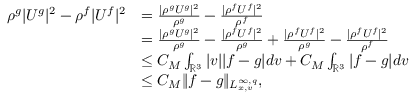<formula> <loc_0><loc_0><loc_500><loc_500>\begin{array} { r l } { \rho ^ { g } | U ^ { g } | ^ { 2 } - \rho ^ { f } | U ^ { f } | ^ { 2 } } & { = \frac { | \rho ^ { g } U ^ { g } | ^ { 2 } } { \rho ^ { g } } - \frac { | \rho ^ { f } U ^ { f } | ^ { 2 } } { \rho ^ { f } } } \\ & { = \frac { | \rho ^ { g } U ^ { g } | ^ { 2 } } { \rho ^ { g } } - \frac { | \rho ^ { f } U ^ { f } | ^ { 2 } } { \rho ^ { g } } + \frac { | \rho ^ { f } U ^ { f } | ^ { 2 } } { \rho ^ { g } } - \frac { | \rho ^ { f } U ^ { f } | ^ { 2 } } { \rho ^ { f } } } \\ & { \leq C _ { M } \int _ { \mathbb { R } ^ { 3 } } | v | | f - g | d v + C _ { M } \int _ { \mathbb { R } ^ { 3 } } | f - g | d v } \\ & { \leq C _ { M } \| f - g \| _ { L _ { x , v } ^ { \infty , q } } , } \end{array}</formula> 